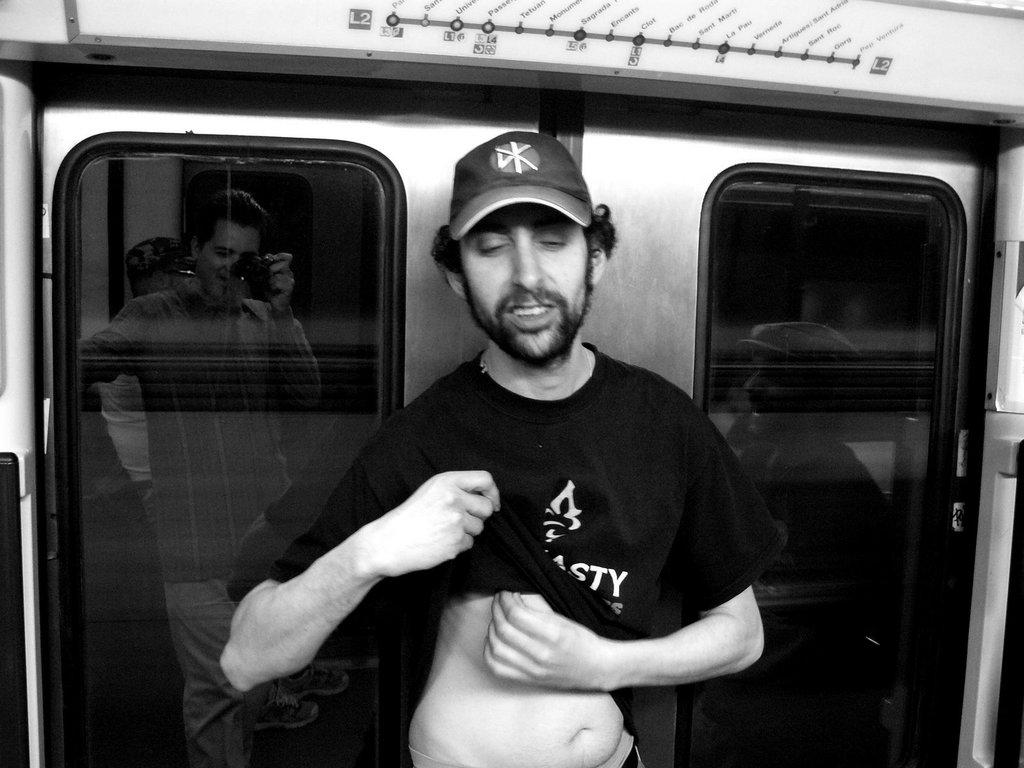What is the person in the image doing? There is a person standing in the image. What is the person wearing on their head? The person is wearing a cap. What can be seen in the background of the image? There are glasses in the background of the image. What is special about the glasses in the image? Reflections of persons are visible in the glasses. Who is holding a camera in the image? One person is holding a camera in the image. What type of suit is the beggar wearing in the image? There is no mention of a suit, a beggar, or space in the image. 